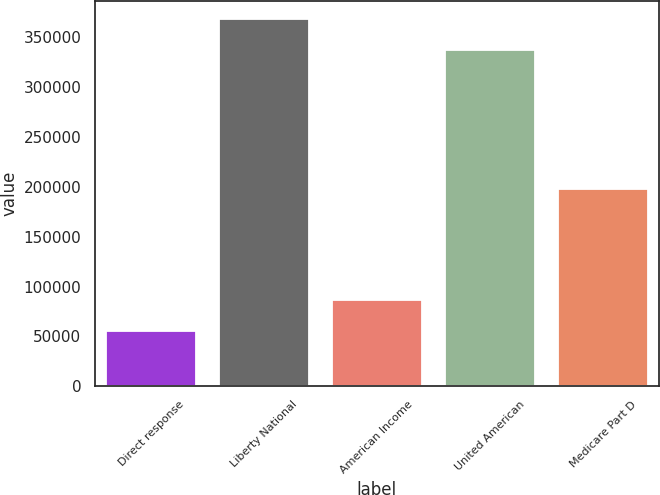Convert chart to OTSL. <chart><loc_0><loc_0><loc_500><loc_500><bar_chart><fcel>Direct response<fcel>Liberty National<fcel>American Income<fcel>United American<fcel>Medicare Part D<nl><fcel>55108<fcel>368262<fcel>86099.9<fcel>337270<fcel>197319<nl></chart> 